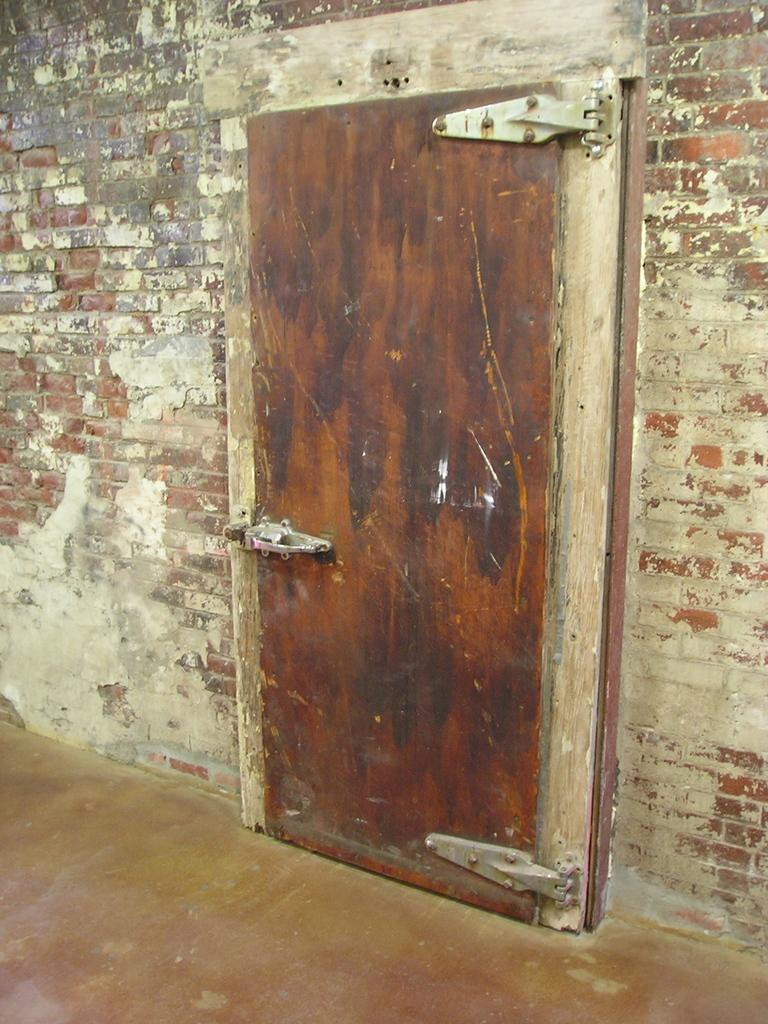What type of structure is visible in the image? There is a brick wall in the image. What feature is present in the brick wall? There is a door in the image. How many fingers can be seen in the image? There are no fingers visible in the image. Is there a flame present in the image? There is no flame present in the image. Are there any dinosaurs visible in the image? There are no dinosaurs visible in the image. 